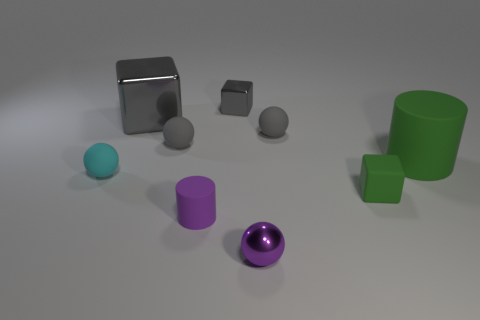Subtract all metal cubes. How many cubes are left? 1 Subtract all purple spheres. How many spheres are left? 3 Subtract 3 cubes. How many cubes are left? 0 Subtract all blue blocks. Subtract all yellow cylinders. How many blocks are left? 3 Subtract all green spheres. How many gray blocks are left? 2 Subtract all purple shiny objects. Subtract all tiny metal spheres. How many objects are left? 7 Add 2 spheres. How many spheres are left? 6 Add 2 green objects. How many green objects exist? 4 Subtract 0 blue blocks. How many objects are left? 9 Subtract all balls. How many objects are left? 5 